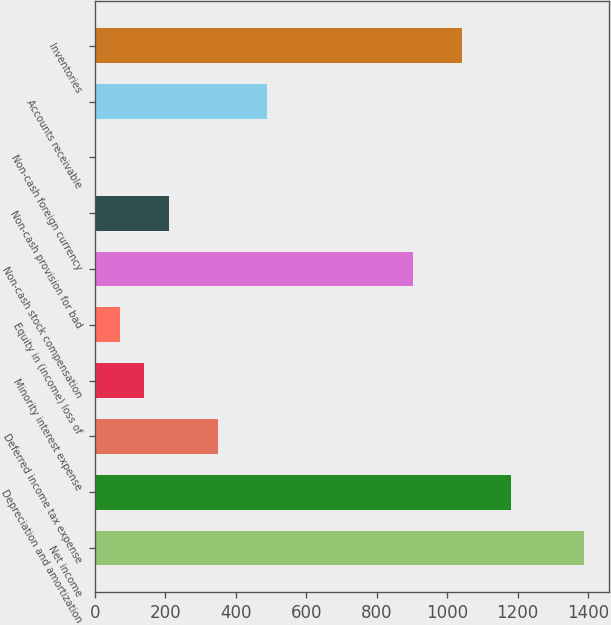Convert chart. <chart><loc_0><loc_0><loc_500><loc_500><bar_chart><fcel>Net income<fcel>Depreciation and amortization<fcel>Deferred income tax expense<fcel>Minority interest expense<fcel>Equity in (income) loss of<fcel>Non-cash stock compensation<fcel>Non-cash provision for bad<fcel>Non-cash foreign currency<fcel>Accounts receivable<fcel>Inventories<nl><fcel>1389.5<fcel>1181.27<fcel>348.35<fcel>140.12<fcel>70.71<fcel>903.63<fcel>209.53<fcel>1.3<fcel>487.17<fcel>1042.45<nl></chart> 